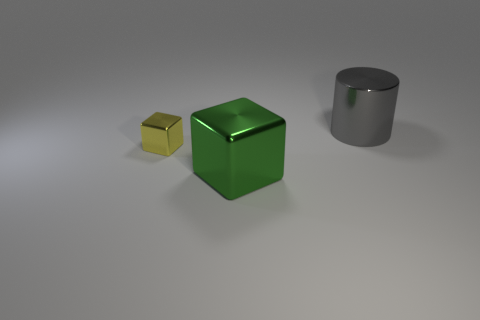Add 1 purple matte things. How many objects exist? 4 Subtract all red spheres. How many green cubes are left? 1 Add 1 big green metal cubes. How many big green metal cubes are left? 2 Add 1 large green metallic objects. How many large green metallic objects exist? 2 Subtract all green cubes. How many cubes are left? 1 Subtract 0 cyan balls. How many objects are left? 3 Subtract all cylinders. How many objects are left? 2 Subtract all cyan cylinders. Subtract all purple cubes. How many cylinders are left? 1 Subtract all big red shiny things. Subtract all cubes. How many objects are left? 1 